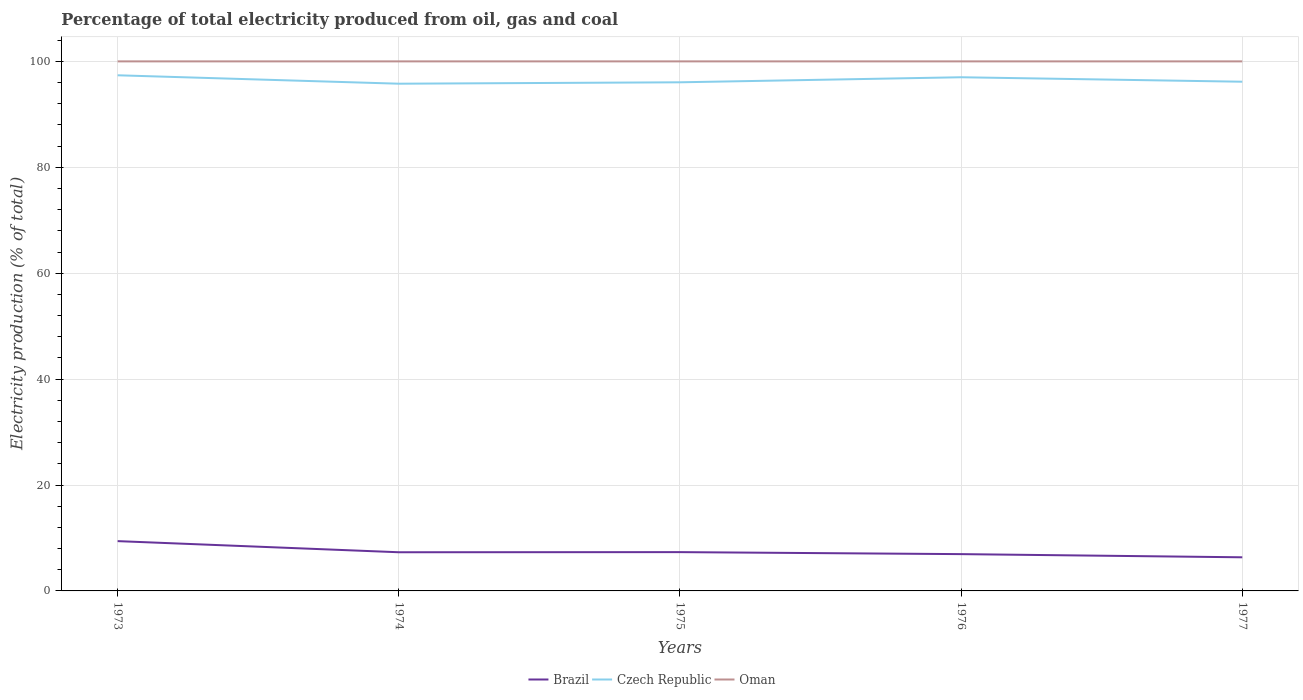Does the line corresponding to Brazil intersect with the line corresponding to Oman?
Offer a very short reply. No. Is the number of lines equal to the number of legend labels?
Provide a succinct answer. Yes. Across all years, what is the maximum electricity production in in Brazil?
Give a very brief answer. 6.35. In which year was the electricity production in in Czech Republic maximum?
Your response must be concise. 1974. What is the total electricity production in in Brazil in the graph?
Provide a succinct answer. 2.1. What is the difference between the highest and the second highest electricity production in in Oman?
Make the answer very short. 0. What is the difference between the highest and the lowest electricity production in in Czech Republic?
Ensure brevity in your answer.  2. How many years are there in the graph?
Ensure brevity in your answer.  5. What is the difference between two consecutive major ticks on the Y-axis?
Your answer should be compact. 20. Does the graph contain any zero values?
Your answer should be very brief. No. How many legend labels are there?
Your response must be concise. 3. How are the legend labels stacked?
Offer a very short reply. Horizontal. What is the title of the graph?
Your answer should be very brief. Percentage of total electricity produced from oil, gas and coal. Does "Myanmar" appear as one of the legend labels in the graph?
Ensure brevity in your answer.  No. What is the label or title of the X-axis?
Provide a succinct answer. Years. What is the label or title of the Y-axis?
Offer a very short reply. Electricity production (% of total). What is the Electricity production (% of total) of Brazil in 1973?
Your answer should be compact. 9.4. What is the Electricity production (% of total) of Czech Republic in 1973?
Ensure brevity in your answer.  97.37. What is the Electricity production (% of total) of Oman in 1973?
Provide a succinct answer. 100. What is the Electricity production (% of total) of Brazil in 1974?
Your answer should be compact. 7.3. What is the Electricity production (% of total) in Czech Republic in 1974?
Offer a very short reply. 95.78. What is the Electricity production (% of total) of Oman in 1974?
Your answer should be very brief. 100. What is the Electricity production (% of total) of Brazil in 1975?
Keep it short and to the point. 7.33. What is the Electricity production (% of total) of Czech Republic in 1975?
Offer a terse response. 96.05. What is the Electricity production (% of total) of Brazil in 1976?
Offer a terse response. 6.95. What is the Electricity production (% of total) of Czech Republic in 1976?
Ensure brevity in your answer.  97. What is the Electricity production (% of total) in Oman in 1976?
Ensure brevity in your answer.  100. What is the Electricity production (% of total) in Brazil in 1977?
Give a very brief answer. 6.35. What is the Electricity production (% of total) in Czech Republic in 1977?
Offer a very short reply. 96.16. What is the Electricity production (% of total) of Oman in 1977?
Your response must be concise. 100. Across all years, what is the maximum Electricity production (% of total) of Brazil?
Provide a short and direct response. 9.4. Across all years, what is the maximum Electricity production (% of total) in Czech Republic?
Give a very brief answer. 97.37. Across all years, what is the minimum Electricity production (% of total) of Brazil?
Ensure brevity in your answer.  6.35. Across all years, what is the minimum Electricity production (% of total) of Czech Republic?
Make the answer very short. 95.78. Across all years, what is the minimum Electricity production (% of total) of Oman?
Offer a terse response. 100. What is the total Electricity production (% of total) of Brazil in the graph?
Offer a very short reply. 37.33. What is the total Electricity production (% of total) in Czech Republic in the graph?
Make the answer very short. 482.37. What is the total Electricity production (% of total) in Oman in the graph?
Offer a terse response. 500. What is the difference between the Electricity production (% of total) in Brazil in 1973 and that in 1974?
Make the answer very short. 2.1. What is the difference between the Electricity production (% of total) of Czech Republic in 1973 and that in 1974?
Ensure brevity in your answer.  1.59. What is the difference between the Electricity production (% of total) in Brazil in 1973 and that in 1975?
Your answer should be very brief. 2.08. What is the difference between the Electricity production (% of total) of Czech Republic in 1973 and that in 1975?
Provide a short and direct response. 1.33. What is the difference between the Electricity production (% of total) in Brazil in 1973 and that in 1976?
Ensure brevity in your answer.  2.45. What is the difference between the Electricity production (% of total) of Czech Republic in 1973 and that in 1976?
Your answer should be very brief. 0.37. What is the difference between the Electricity production (% of total) in Brazil in 1973 and that in 1977?
Ensure brevity in your answer.  3.05. What is the difference between the Electricity production (% of total) of Czech Republic in 1973 and that in 1977?
Your answer should be compact. 1.22. What is the difference between the Electricity production (% of total) in Brazil in 1974 and that in 1975?
Your response must be concise. -0.02. What is the difference between the Electricity production (% of total) in Czech Republic in 1974 and that in 1975?
Keep it short and to the point. -0.27. What is the difference between the Electricity production (% of total) of Oman in 1974 and that in 1975?
Keep it short and to the point. 0. What is the difference between the Electricity production (% of total) of Brazil in 1974 and that in 1976?
Give a very brief answer. 0.35. What is the difference between the Electricity production (% of total) of Czech Republic in 1974 and that in 1976?
Offer a terse response. -1.22. What is the difference between the Electricity production (% of total) of Oman in 1974 and that in 1976?
Offer a terse response. 0. What is the difference between the Electricity production (% of total) of Brazil in 1974 and that in 1977?
Give a very brief answer. 0.95. What is the difference between the Electricity production (% of total) in Czech Republic in 1974 and that in 1977?
Your answer should be very brief. -0.37. What is the difference between the Electricity production (% of total) in Oman in 1974 and that in 1977?
Your response must be concise. 0. What is the difference between the Electricity production (% of total) in Brazil in 1975 and that in 1976?
Provide a short and direct response. 0.38. What is the difference between the Electricity production (% of total) in Czech Republic in 1975 and that in 1976?
Offer a terse response. -0.95. What is the difference between the Electricity production (% of total) in Oman in 1975 and that in 1976?
Make the answer very short. 0. What is the difference between the Electricity production (% of total) of Brazil in 1975 and that in 1977?
Your response must be concise. 0.97. What is the difference between the Electricity production (% of total) of Czech Republic in 1975 and that in 1977?
Your response must be concise. -0.11. What is the difference between the Electricity production (% of total) of Oman in 1975 and that in 1977?
Offer a very short reply. 0. What is the difference between the Electricity production (% of total) of Brazil in 1976 and that in 1977?
Ensure brevity in your answer.  0.6. What is the difference between the Electricity production (% of total) in Czech Republic in 1976 and that in 1977?
Make the answer very short. 0.84. What is the difference between the Electricity production (% of total) in Brazil in 1973 and the Electricity production (% of total) in Czech Republic in 1974?
Offer a very short reply. -86.38. What is the difference between the Electricity production (% of total) of Brazil in 1973 and the Electricity production (% of total) of Oman in 1974?
Provide a short and direct response. -90.6. What is the difference between the Electricity production (% of total) of Czech Republic in 1973 and the Electricity production (% of total) of Oman in 1974?
Your answer should be very brief. -2.63. What is the difference between the Electricity production (% of total) in Brazil in 1973 and the Electricity production (% of total) in Czech Republic in 1975?
Your answer should be compact. -86.65. What is the difference between the Electricity production (% of total) in Brazil in 1973 and the Electricity production (% of total) in Oman in 1975?
Your response must be concise. -90.6. What is the difference between the Electricity production (% of total) of Czech Republic in 1973 and the Electricity production (% of total) of Oman in 1975?
Offer a terse response. -2.63. What is the difference between the Electricity production (% of total) in Brazil in 1973 and the Electricity production (% of total) in Czech Republic in 1976?
Keep it short and to the point. -87.6. What is the difference between the Electricity production (% of total) in Brazil in 1973 and the Electricity production (% of total) in Oman in 1976?
Keep it short and to the point. -90.6. What is the difference between the Electricity production (% of total) of Czech Republic in 1973 and the Electricity production (% of total) of Oman in 1976?
Make the answer very short. -2.63. What is the difference between the Electricity production (% of total) of Brazil in 1973 and the Electricity production (% of total) of Czech Republic in 1977?
Offer a terse response. -86.75. What is the difference between the Electricity production (% of total) in Brazil in 1973 and the Electricity production (% of total) in Oman in 1977?
Your response must be concise. -90.6. What is the difference between the Electricity production (% of total) in Czech Republic in 1973 and the Electricity production (% of total) in Oman in 1977?
Provide a succinct answer. -2.63. What is the difference between the Electricity production (% of total) of Brazil in 1974 and the Electricity production (% of total) of Czech Republic in 1975?
Your answer should be very brief. -88.75. What is the difference between the Electricity production (% of total) in Brazil in 1974 and the Electricity production (% of total) in Oman in 1975?
Offer a terse response. -92.7. What is the difference between the Electricity production (% of total) in Czech Republic in 1974 and the Electricity production (% of total) in Oman in 1975?
Offer a terse response. -4.22. What is the difference between the Electricity production (% of total) of Brazil in 1974 and the Electricity production (% of total) of Czech Republic in 1976?
Offer a very short reply. -89.7. What is the difference between the Electricity production (% of total) in Brazil in 1974 and the Electricity production (% of total) in Oman in 1976?
Offer a very short reply. -92.7. What is the difference between the Electricity production (% of total) of Czech Republic in 1974 and the Electricity production (% of total) of Oman in 1976?
Provide a succinct answer. -4.22. What is the difference between the Electricity production (% of total) of Brazil in 1974 and the Electricity production (% of total) of Czech Republic in 1977?
Your answer should be very brief. -88.86. What is the difference between the Electricity production (% of total) of Brazil in 1974 and the Electricity production (% of total) of Oman in 1977?
Give a very brief answer. -92.7. What is the difference between the Electricity production (% of total) of Czech Republic in 1974 and the Electricity production (% of total) of Oman in 1977?
Your answer should be very brief. -4.22. What is the difference between the Electricity production (% of total) of Brazil in 1975 and the Electricity production (% of total) of Czech Republic in 1976?
Give a very brief answer. -89.68. What is the difference between the Electricity production (% of total) in Brazil in 1975 and the Electricity production (% of total) in Oman in 1976?
Offer a terse response. -92.67. What is the difference between the Electricity production (% of total) in Czech Republic in 1975 and the Electricity production (% of total) in Oman in 1976?
Your answer should be very brief. -3.95. What is the difference between the Electricity production (% of total) of Brazil in 1975 and the Electricity production (% of total) of Czech Republic in 1977?
Keep it short and to the point. -88.83. What is the difference between the Electricity production (% of total) of Brazil in 1975 and the Electricity production (% of total) of Oman in 1977?
Keep it short and to the point. -92.67. What is the difference between the Electricity production (% of total) in Czech Republic in 1975 and the Electricity production (% of total) in Oman in 1977?
Make the answer very short. -3.95. What is the difference between the Electricity production (% of total) of Brazil in 1976 and the Electricity production (% of total) of Czech Republic in 1977?
Provide a short and direct response. -89.21. What is the difference between the Electricity production (% of total) of Brazil in 1976 and the Electricity production (% of total) of Oman in 1977?
Provide a succinct answer. -93.05. What is the difference between the Electricity production (% of total) of Czech Republic in 1976 and the Electricity production (% of total) of Oman in 1977?
Provide a short and direct response. -3. What is the average Electricity production (% of total) of Brazil per year?
Give a very brief answer. 7.47. What is the average Electricity production (% of total) of Czech Republic per year?
Provide a succinct answer. 96.47. In the year 1973, what is the difference between the Electricity production (% of total) of Brazil and Electricity production (% of total) of Czech Republic?
Provide a short and direct response. -87.97. In the year 1973, what is the difference between the Electricity production (% of total) of Brazil and Electricity production (% of total) of Oman?
Offer a terse response. -90.6. In the year 1973, what is the difference between the Electricity production (% of total) in Czech Republic and Electricity production (% of total) in Oman?
Offer a very short reply. -2.63. In the year 1974, what is the difference between the Electricity production (% of total) in Brazil and Electricity production (% of total) in Czech Republic?
Ensure brevity in your answer.  -88.48. In the year 1974, what is the difference between the Electricity production (% of total) of Brazil and Electricity production (% of total) of Oman?
Keep it short and to the point. -92.7. In the year 1974, what is the difference between the Electricity production (% of total) of Czech Republic and Electricity production (% of total) of Oman?
Offer a very short reply. -4.22. In the year 1975, what is the difference between the Electricity production (% of total) in Brazil and Electricity production (% of total) in Czech Republic?
Offer a very short reply. -88.72. In the year 1975, what is the difference between the Electricity production (% of total) of Brazil and Electricity production (% of total) of Oman?
Make the answer very short. -92.67. In the year 1975, what is the difference between the Electricity production (% of total) of Czech Republic and Electricity production (% of total) of Oman?
Keep it short and to the point. -3.95. In the year 1976, what is the difference between the Electricity production (% of total) of Brazil and Electricity production (% of total) of Czech Republic?
Ensure brevity in your answer.  -90.05. In the year 1976, what is the difference between the Electricity production (% of total) of Brazil and Electricity production (% of total) of Oman?
Give a very brief answer. -93.05. In the year 1976, what is the difference between the Electricity production (% of total) in Czech Republic and Electricity production (% of total) in Oman?
Ensure brevity in your answer.  -3. In the year 1977, what is the difference between the Electricity production (% of total) of Brazil and Electricity production (% of total) of Czech Republic?
Your answer should be very brief. -89.81. In the year 1977, what is the difference between the Electricity production (% of total) in Brazil and Electricity production (% of total) in Oman?
Offer a terse response. -93.65. In the year 1977, what is the difference between the Electricity production (% of total) of Czech Republic and Electricity production (% of total) of Oman?
Keep it short and to the point. -3.84. What is the ratio of the Electricity production (% of total) of Brazil in 1973 to that in 1974?
Ensure brevity in your answer.  1.29. What is the ratio of the Electricity production (% of total) in Czech Republic in 1973 to that in 1974?
Keep it short and to the point. 1.02. What is the ratio of the Electricity production (% of total) of Brazil in 1973 to that in 1975?
Offer a terse response. 1.28. What is the ratio of the Electricity production (% of total) of Czech Republic in 1973 to that in 1975?
Offer a very short reply. 1.01. What is the ratio of the Electricity production (% of total) of Oman in 1973 to that in 1975?
Keep it short and to the point. 1. What is the ratio of the Electricity production (% of total) of Brazil in 1973 to that in 1976?
Offer a very short reply. 1.35. What is the ratio of the Electricity production (% of total) of Oman in 1973 to that in 1976?
Provide a short and direct response. 1. What is the ratio of the Electricity production (% of total) of Brazil in 1973 to that in 1977?
Offer a terse response. 1.48. What is the ratio of the Electricity production (% of total) in Czech Republic in 1973 to that in 1977?
Make the answer very short. 1.01. What is the ratio of the Electricity production (% of total) in Oman in 1973 to that in 1977?
Offer a terse response. 1. What is the ratio of the Electricity production (% of total) of Brazil in 1974 to that in 1975?
Make the answer very short. 1. What is the ratio of the Electricity production (% of total) of Brazil in 1974 to that in 1976?
Provide a short and direct response. 1.05. What is the ratio of the Electricity production (% of total) of Czech Republic in 1974 to that in 1976?
Make the answer very short. 0.99. What is the ratio of the Electricity production (% of total) in Brazil in 1974 to that in 1977?
Offer a terse response. 1.15. What is the ratio of the Electricity production (% of total) of Brazil in 1975 to that in 1976?
Make the answer very short. 1.05. What is the ratio of the Electricity production (% of total) in Czech Republic in 1975 to that in 1976?
Your answer should be compact. 0.99. What is the ratio of the Electricity production (% of total) in Oman in 1975 to that in 1976?
Ensure brevity in your answer.  1. What is the ratio of the Electricity production (% of total) in Brazil in 1975 to that in 1977?
Keep it short and to the point. 1.15. What is the ratio of the Electricity production (% of total) in Czech Republic in 1975 to that in 1977?
Keep it short and to the point. 1. What is the ratio of the Electricity production (% of total) in Oman in 1975 to that in 1977?
Provide a succinct answer. 1. What is the ratio of the Electricity production (% of total) in Brazil in 1976 to that in 1977?
Provide a succinct answer. 1.09. What is the ratio of the Electricity production (% of total) of Czech Republic in 1976 to that in 1977?
Ensure brevity in your answer.  1.01. What is the difference between the highest and the second highest Electricity production (% of total) in Brazil?
Provide a succinct answer. 2.08. What is the difference between the highest and the second highest Electricity production (% of total) of Czech Republic?
Your answer should be very brief. 0.37. What is the difference between the highest and the lowest Electricity production (% of total) of Brazil?
Provide a succinct answer. 3.05. What is the difference between the highest and the lowest Electricity production (% of total) in Czech Republic?
Offer a terse response. 1.59. What is the difference between the highest and the lowest Electricity production (% of total) in Oman?
Offer a terse response. 0. 